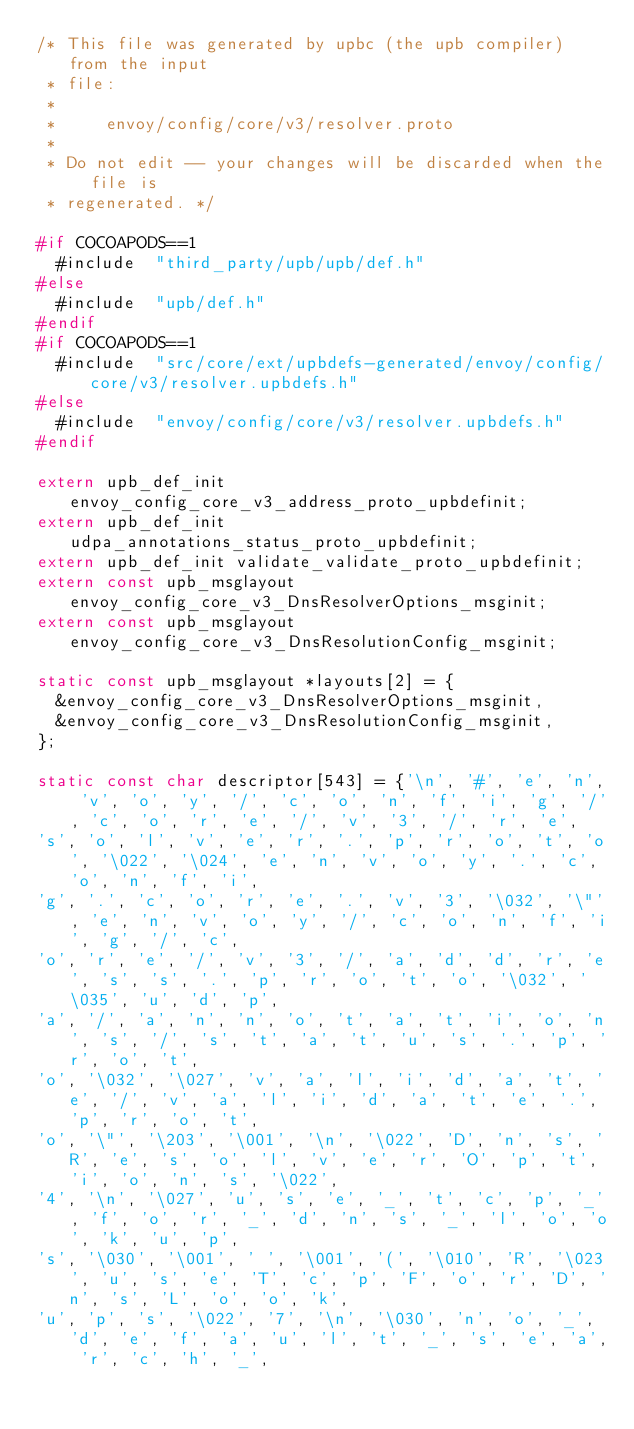<code> <loc_0><loc_0><loc_500><loc_500><_C_>/* This file was generated by upbc (the upb compiler) from the input
 * file:
 *
 *     envoy/config/core/v3/resolver.proto
 *
 * Do not edit -- your changes will be discarded when the file is
 * regenerated. */

#if COCOAPODS==1
  #include  "third_party/upb/upb/def.h"
#else
  #include  "upb/def.h"
#endif
#if COCOAPODS==1
  #include  "src/core/ext/upbdefs-generated/envoy/config/core/v3/resolver.upbdefs.h"
#else
  #include  "envoy/config/core/v3/resolver.upbdefs.h"
#endif

extern upb_def_init envoy_config_core_v3_address_proto_upbdefinit;
extern upb_def_init udpa_annotations_status_proto_upbdefinit;
extern upb_def_init validate_validate_proto_upbdefinit;
extern const upb_msglayout envoy_config_core_v3_DnsResolverOptions_msginit;
extern const upb_msglayout envoy_config_core_v3_DnsResolutionConfig_msginit;

static const upb_msglayout *layouts[2] = {
  &envoy_config_core_v3_DnsResolverOptions_msginit,
  &envoy_config_core_v3_DnsResolutionConfig_msginit,
};

static const char descriptor[543] = {'\n', '#', 'e', 'n', 'v', 'o', 'y', '/', 'c', 'o', 'n', 'f', 'i', 'g', '/', 'c', 'o', 'r', 'e', '/', 'v', '3', '/', 'r', 'e', 
's', 'o', 'l', 'v', 'e', 'r', '.', 'p', 'r', 'o', 't', 'o', '\022', '\024', 'e', 'n', 'v', 'o', 'y', '.', 'c', 'o', 'n', 'f', 'i', 
'g', '.', 'c', 'o', 'r', 'e', '.', 'v', '3', '\032', '\"', 'e', 'n', 'v', 'o', 'y', '/', 'c', 'o', 'n', 'f', 'i', 'g', '/', 'c', 
'o', 'r', 'e', '/', 'v', '3', '/', 'a', 'd', 'd', 'r', 'e', 's', 's', '.', 'p', 'r', 'o', 't', 'o', '\032', '\035', 'u', 'd', 'p', 
'a', '/', 'a', 'n', 'n', 'o', 't', 'a', 't', 'i', 'o', 'n', 's', '/', 's', 't', 'a', 't', 'u', 's', '.', 'p', 'r', 'o', 't', 
'o', '\032', '\027', 'v', 'a', 'l', 'i', 'd', 'a', 't', 'e', '/', 'v', 'a', 'l', 'i', 'd', 'a', 't', 'e', '.', 'p', 'r', 'o', 't', 
'o', '\"', '\203', '\001', '\n', '\022', 'D', 'n', 's', 'R', 'e', 's', 'o', 'l', 'v', 'e', 'r', 'O', 'p', 't', 'i', 'o', 'n', 's', '\022', 
'4', '\n', '\027', 'u', 's', 'e', '_', 't', 'c', 'p', '_', 'f', 'o', 'r', '_', 'd', 'n', 's', '_', 'l', 'o', 'o', 'k', 'u', 'p', 
's', '\030', '\001', ' ', '\001', '(', '\010', 'R', '\023', 'u', 's', 'e', 'T', 'c', 'p', 'F', 'o', 'r', 'D', 'n', 's', 'L', 'o', 'o', 'k', 
'u', 'p', 's', '\022', '7', '\n', '\030', 'n', 'o', '_', 'd', 'e', 'f', 'a', 'u', 'l', 't', '_', 's', 'e', 'a', 'r', 'c', 'h', '_', </code> 